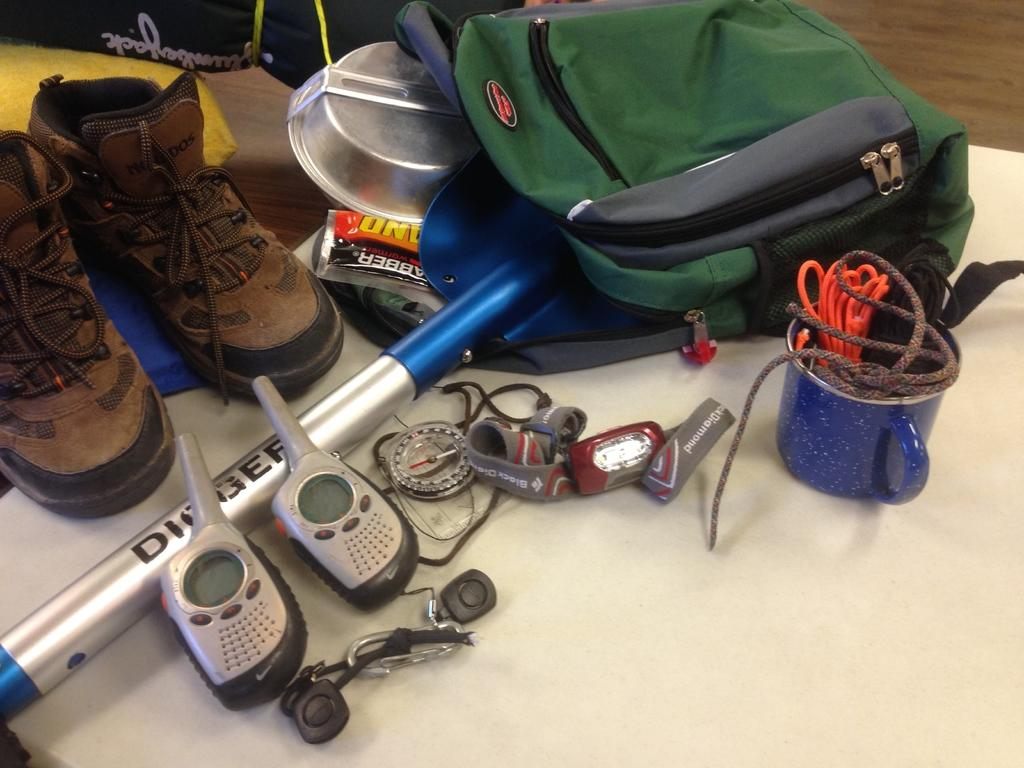What type of footwear is visible in the image? There are shoes in the image. What other items can be seen in the image besides shoes? There are bags, a cup, threads, two walkie-talkies, and other objects on the table in the image. What might be used for communication in the image? There are two walkie-talkies in the image, which can be used for communication. What is the material of the threads in the image? The provided facts do not specify the material of the threads in the image. How does the image compare to the morning? The image does not have any direct comparison to the morning, as it only shows objects such as shoes, bags, a cup, threads, walkie-talkies, and other objects on a table. 